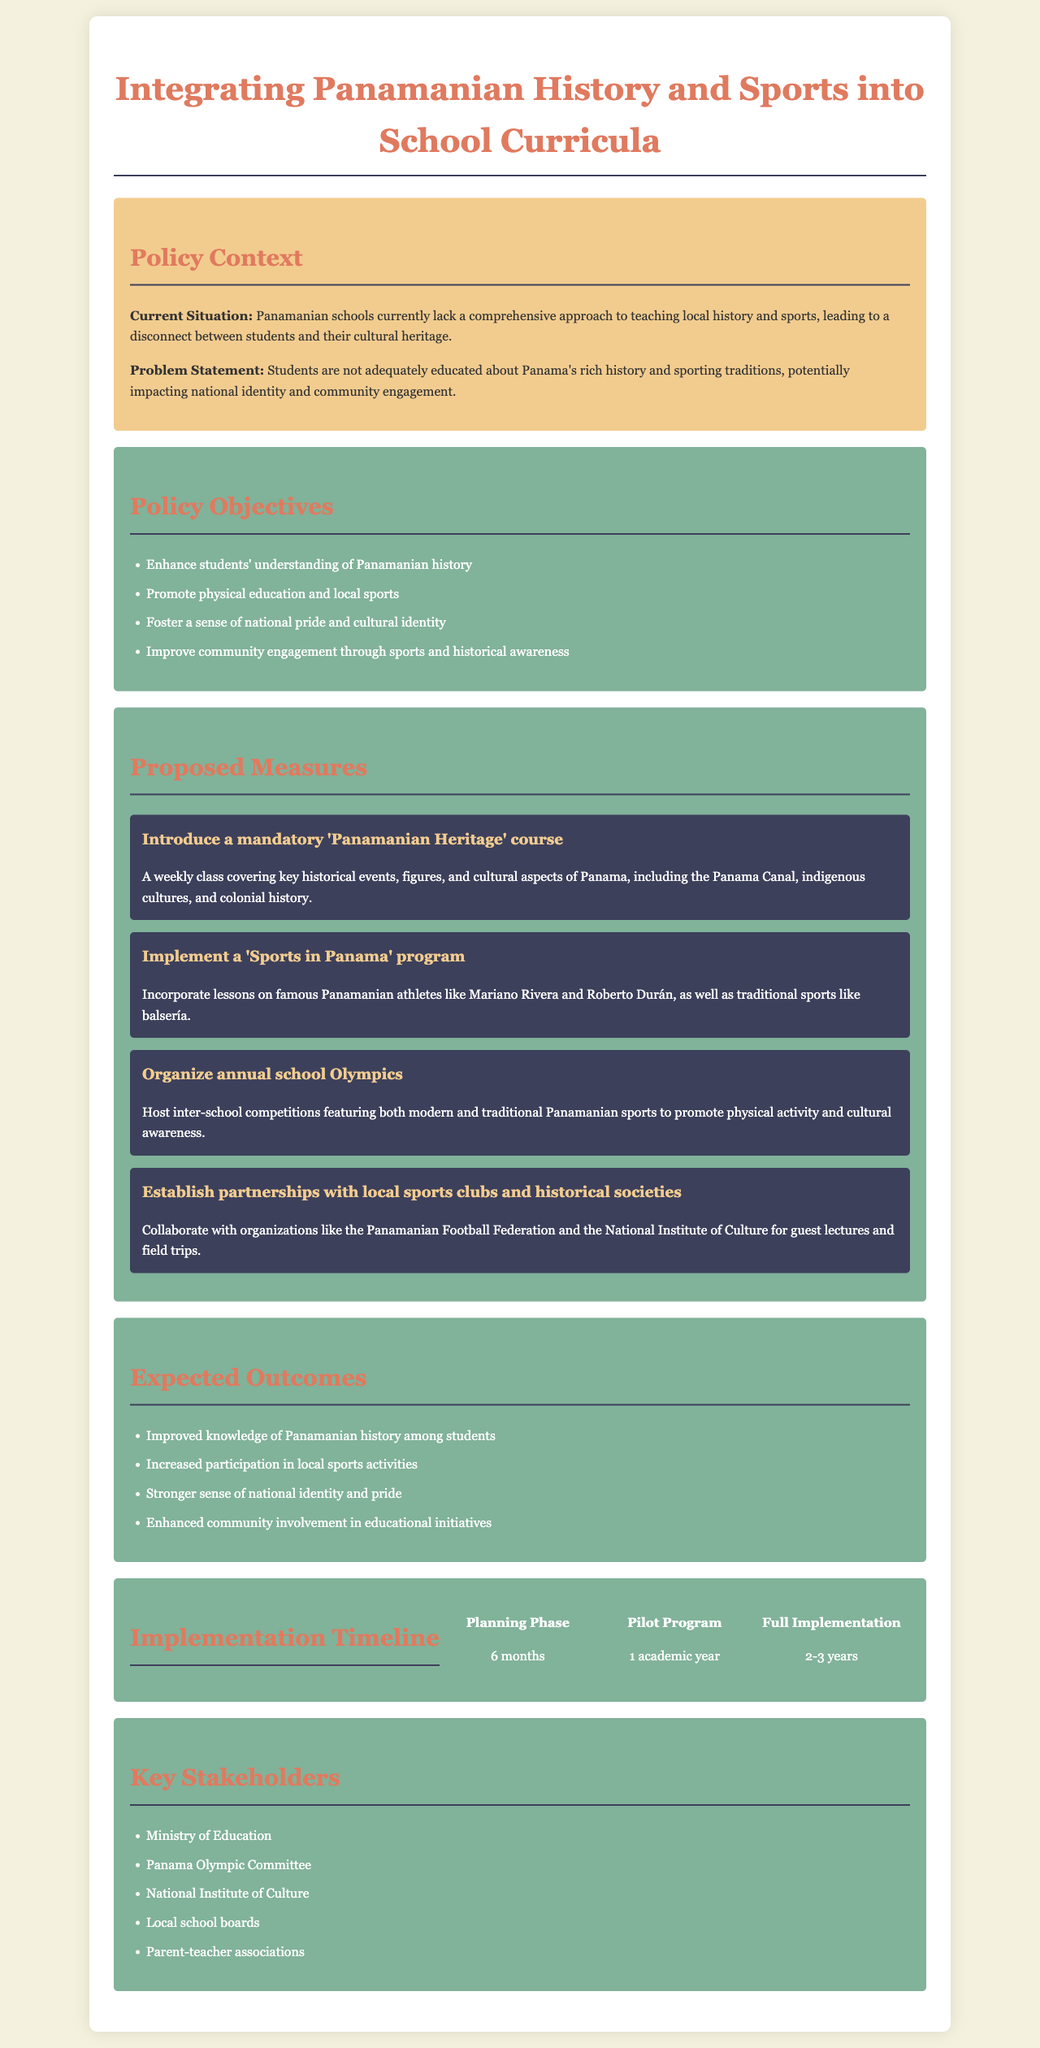what is the title of the policy document? The title of the document is presented prominently at the top and reflects the focus of the policy.
Answer: Integrating Panamanian History and Sports into School Curricula what is the main problem identified in the document? The problem statement summarizes the key issue that the policy aims to address regarding education in the context of cultural heritage.
Answer: Students are not adequately educated about Panama's rich history and sporting traditions how many objectives are listed in the policy? The number of objectives outlined in the document can be found in the policy objectives section.
Answer: Four who is responsible for implementing the proposed measures? The key stakeholders responsible for the implementation of the policy are listed towards the end of the document.
Answer: Ministry of Education what duration is allocated for the planning phase? The implementation timeline specifies the duration for each phase of the policy.
Answer: 6 months name one proposed measure to enhance physical education. The measures section details strategies to promote sports and education, one of which pertains to physical education.
Answer: Implement a 'Sports in Panama' program what is the expected outcome related to community involvement? The expected outcomes provide insights into how this policy aims to impact community engagement.
Answer: Enhanced community involvement in educational initiatives how long is the pilot program set to last? The timeline of the pilot program is mentioned clearly in the implementation timeline section.
Answer: 1 academic year 